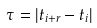<formula> <loc_0><loc_0><loc_500><loc_500>\tau = | t _ { i + r } - t _ { i } |</formula> 